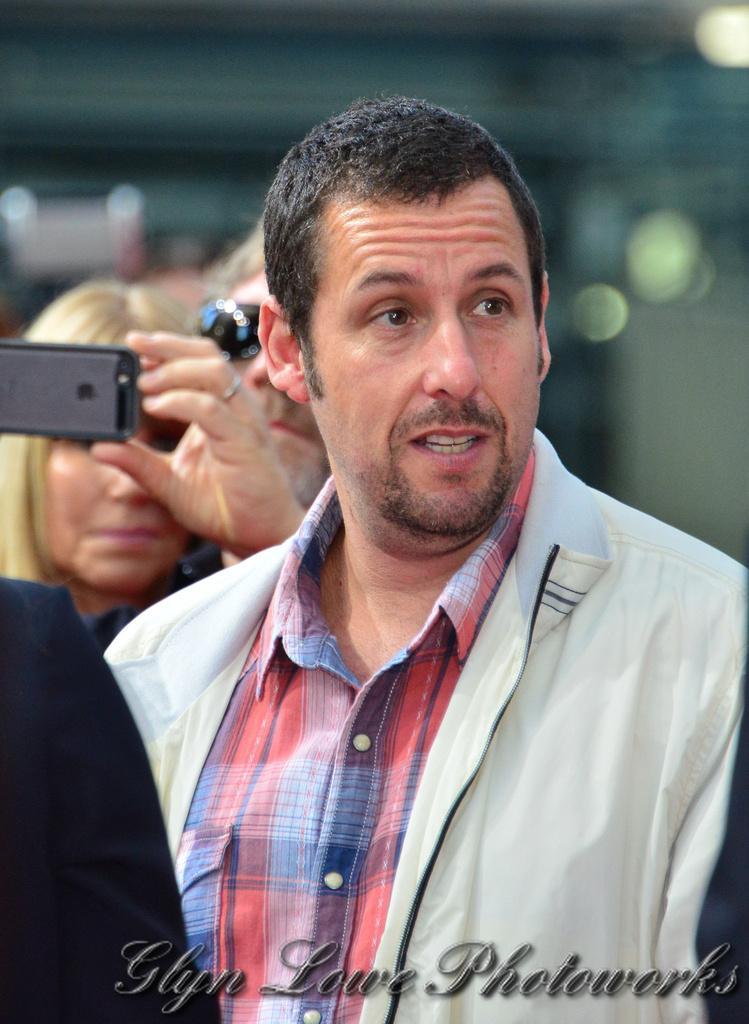In one or two sentences, can you explain what this image depicts? In this image, few peoples are there. The middle person is seeing some where. At the background, the human is wearing goggles and he hold mobile on his hand. 